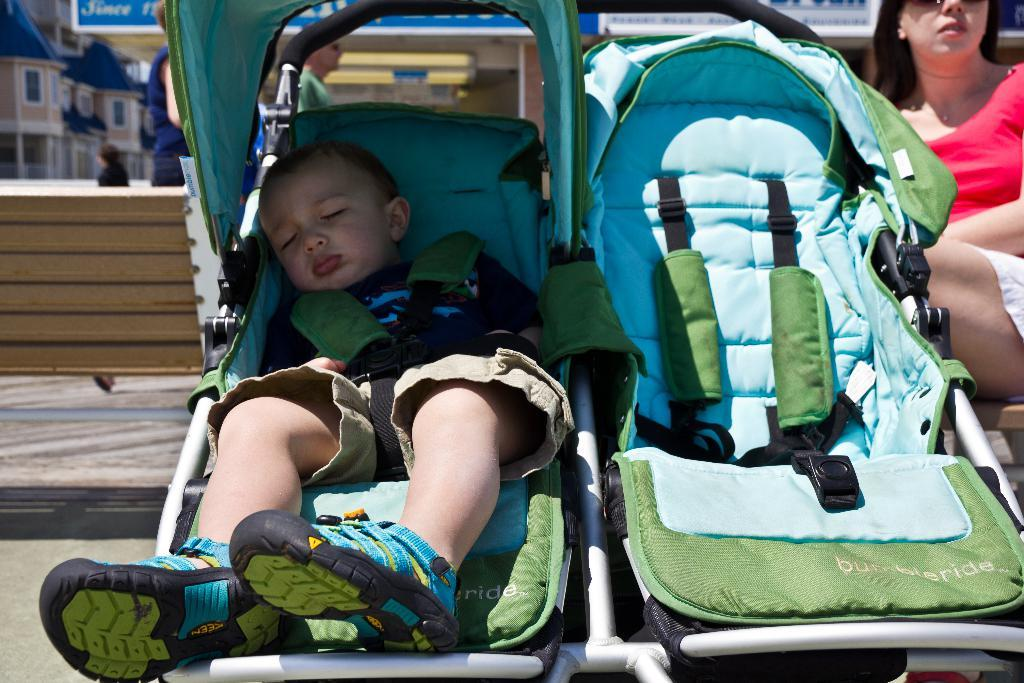What is the main subject of the image? There is a boy in a baby carrier in the image. Who is present on the right side of the image? There is a woman on the right side of the image. What can be seen in the background of the image? There are people and buildings in the background of the image. What type of water activity is the boy participating in the image? There is no water activity present in the image; the boy is in a baby carrier. 